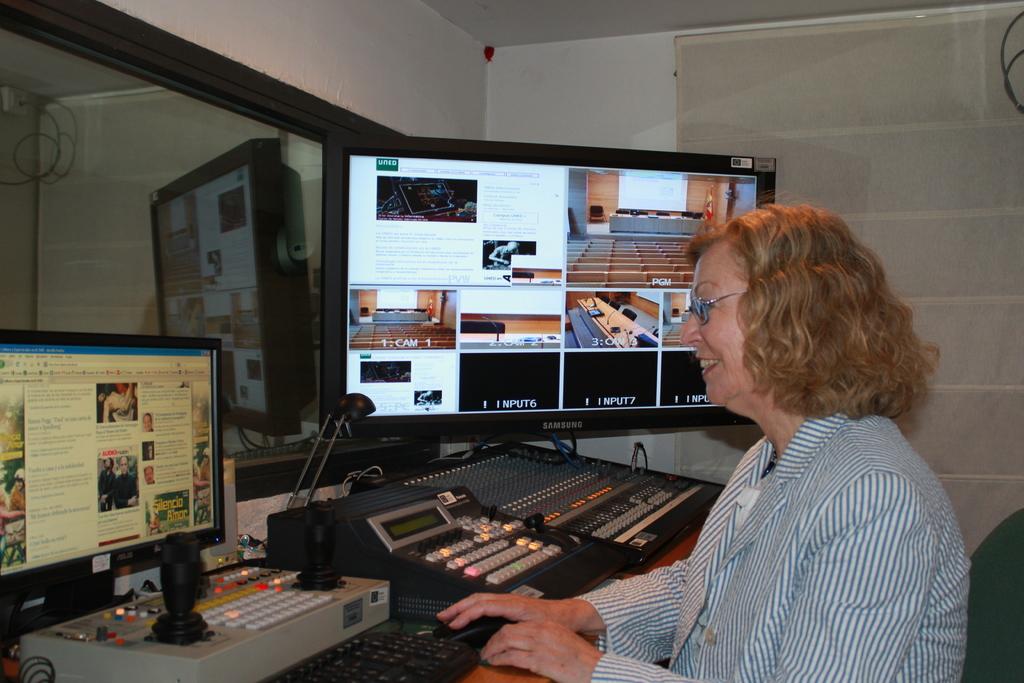What is the brand of the giant monitor?
Offer a terse response. Samsung. What does it say on the first black box?
Give a very brief answer. Input 6. 